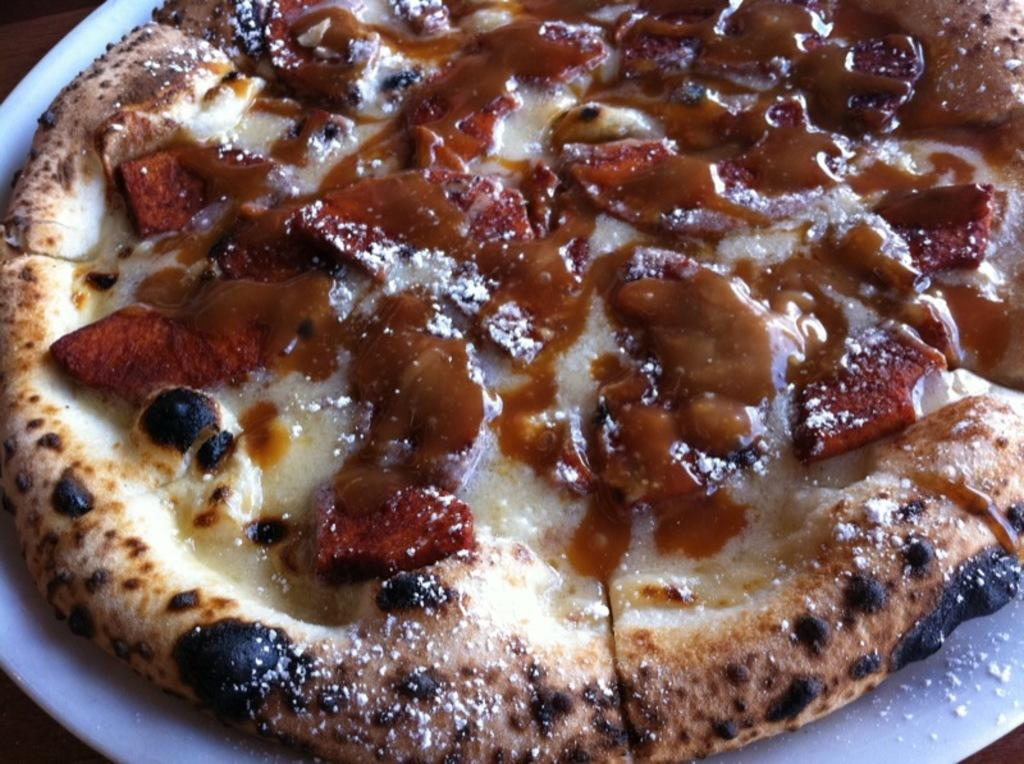What object is present on the plate in the image? There are slices of pizza on the plate. What is the color of the plate? The plate is white in color. How many clovers can be seen growing on the pizza in the image? There are no clovers present in the image, as it features a plate with slices of pizza. 